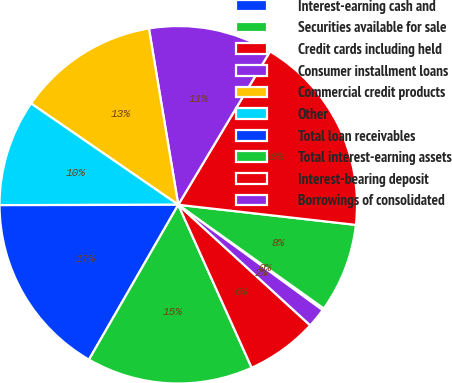<chart> <loc_0><loc_0><loc_500><loc_500><pie_chart><fcel>Interest-earning cash and<fcel>Securities available for sale<fcel>Credit cards including held<fcel>Consumer installment loans<fcel>Commercial credit products<fcel>Other<fcel>Total loan receivables<fcel>Total interest-earning assets<fcel>Interest-bearing deposit<fcel>Borrowings of consolidated<nl><fcel>0.18%<fcel>8.06%<fcel>18.21%<fcel>11.21%<fcel>12.78%<fcel>9.63%<fcel>16.64%<fcel>15.06%<fcel>6.48%<fcel>1.75%<nl></chart> 